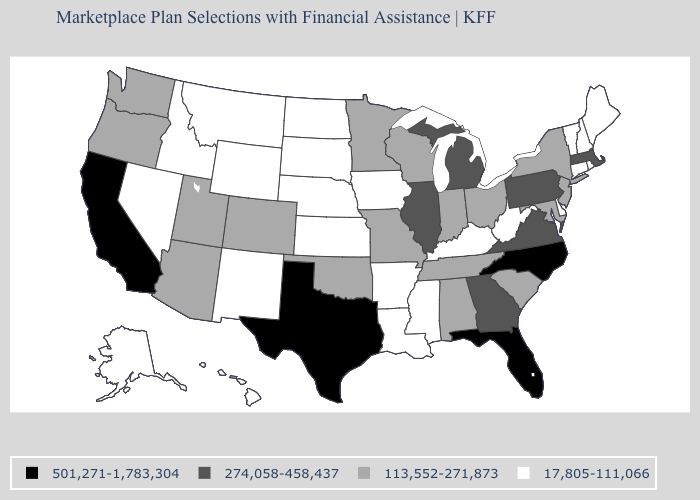What is the value of Minnesota?
Concise answer only. 113,552-271,873. Which states hav the highest value in the MidWest?
Write a very short answer. Illinois, Michigan. Among the states that border Texas , which have the lowest value?
Concise answer only. Arkansas, Louisiana, New Mexico. What is the value of Connecticut?
Short answer required. 17,805-111,066. Does Massachusetts have the same value as Illinois?
Give a very brief answer. Yes. What is the value of Wyoming?
Keep it brief. 17,805-111,066. Does the first symbol in the legend represent the smallest category?
Be succinct. No. What is the value of Missouri?
Concise answer only. 113,552-271,873. What is the value of West Virginia?
Short answer required. 17,805-111,066. Which states hav the highest value in the Northeast?
Write a very short answer. Massachusetts, Pennsylvania. Does Wisconsin have the highest value in the MidWest?
Write a very short answer. No. Among the states that border Virginia , does Kentucky have the highest value?
Short answer required. No. Name the states that have a value in the range 113,552-271,873?
Answer briefly. Alabama, Arizona, Colorado, Indiana, Maryland, Minnesota, Missouri, New Jersey, New York, Ohio, Oklahoma, Oregon, South Carolina, Tennessee, Utah, Washington, Wisconsin. Does the map have missing data?
Keep it brief. No. Does New Jersey have the lowest value in the Northeast?
Write a very short answer. No. 